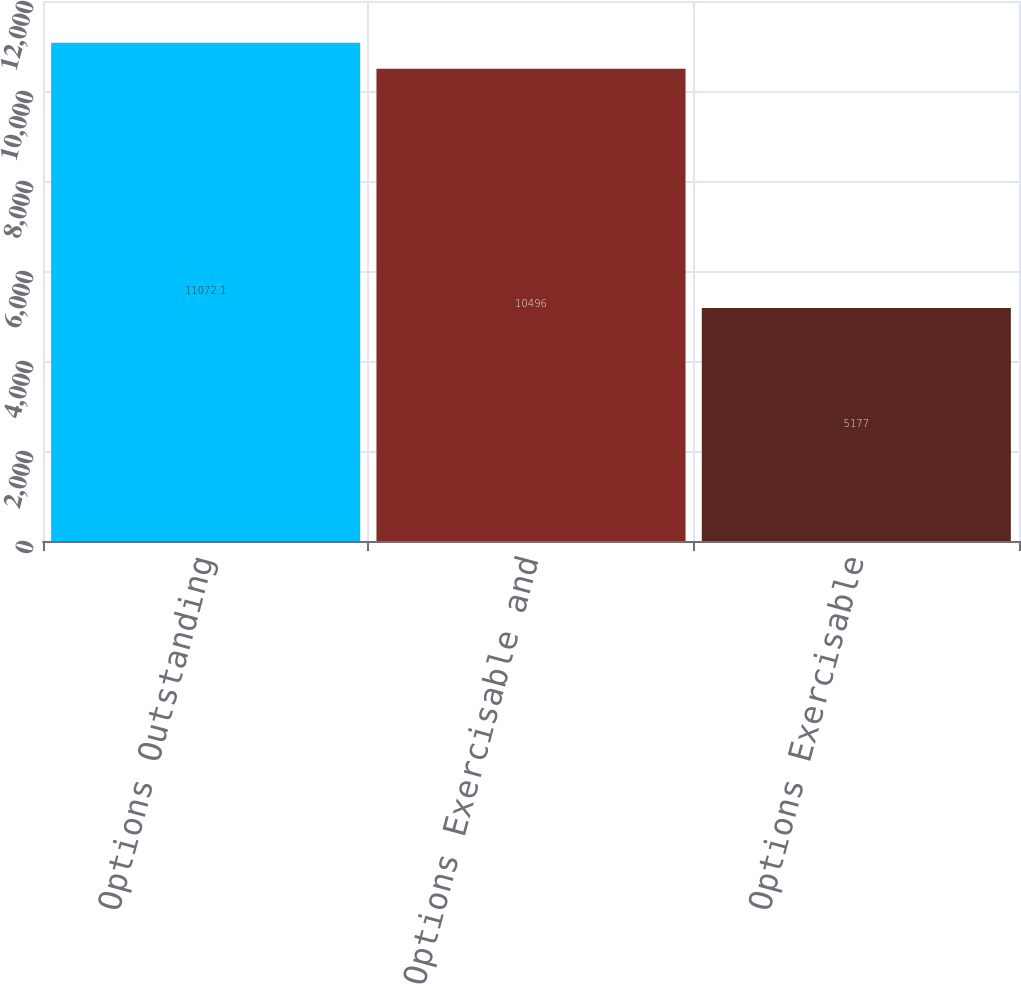Convert chart to OTSL. <chart><loc_0><loc_0><loc_500><loc_500><bar_chart><fcel>Options Outstanding<fcel>Options Exercisable and<fcel>Options Exercisable<nl><fcel>11072.1<fcel>10496<fcel>5177<nl></chart> 